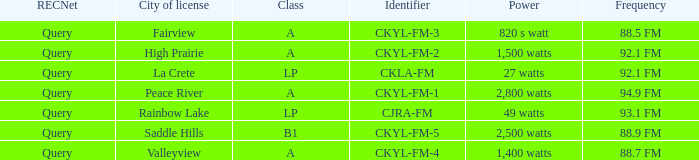What is the power with 88.5 fm frequency 820 s watt. 